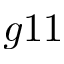<formula> <loc_0><loc_0><loc_500><loc_500>g 1 1</formula> 